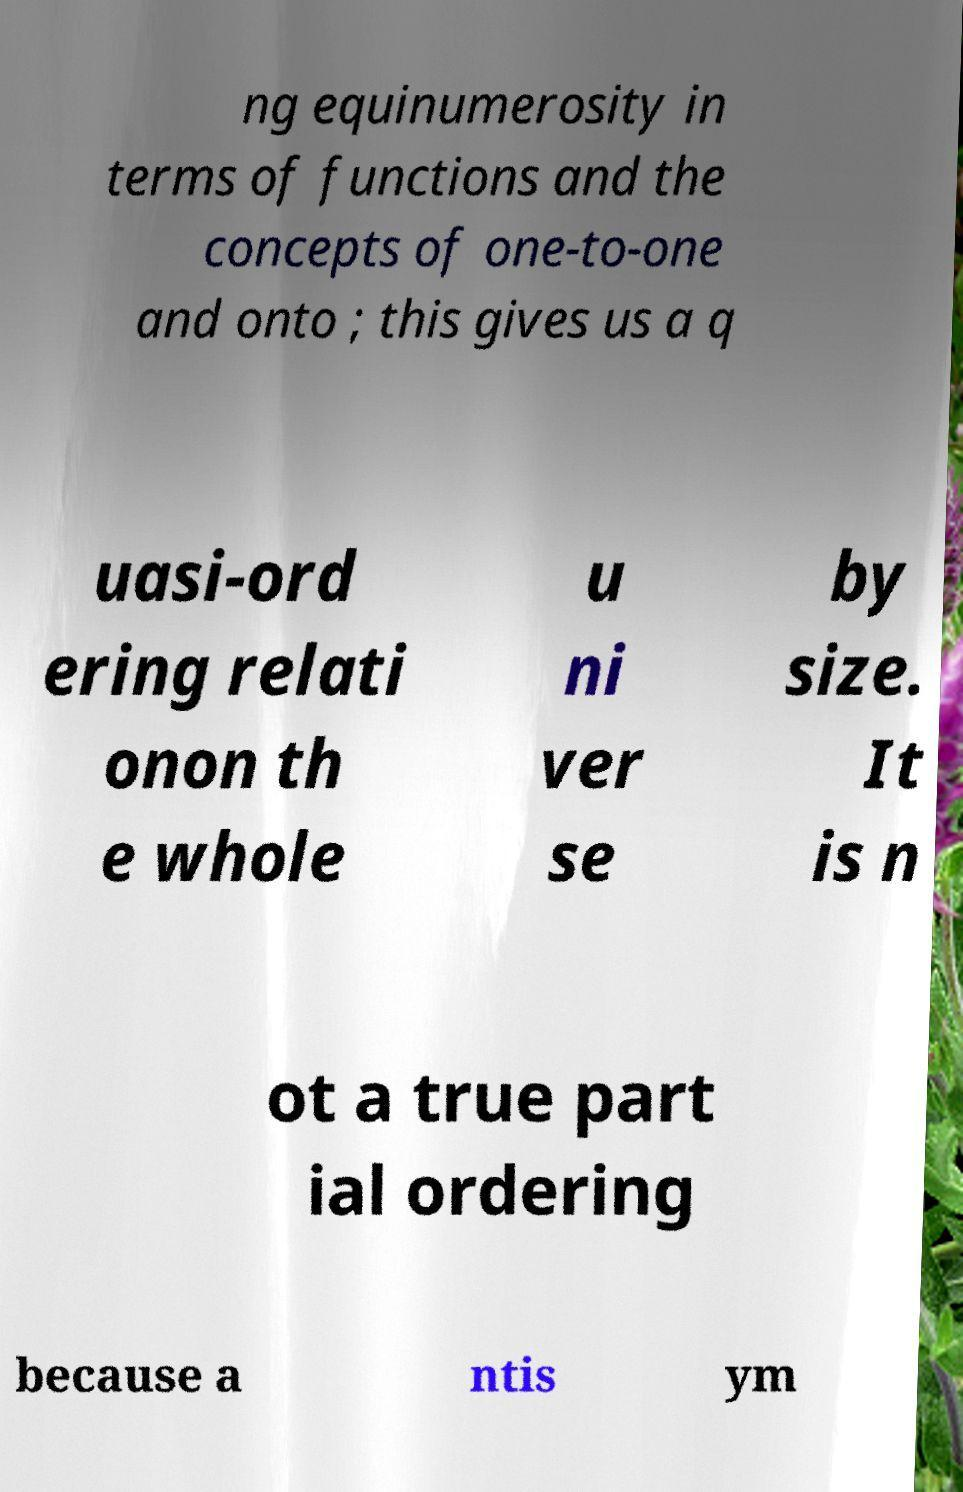Please read and relay the text visible in this image. What does it say? ng equinumerosity in terms of functions and the concepts of one-to-one and onto ; this gives us a q uasi-ord ering relati onon th e whole u ni ver se by size. It is n ot a true part ial ordering because a ntis ym 